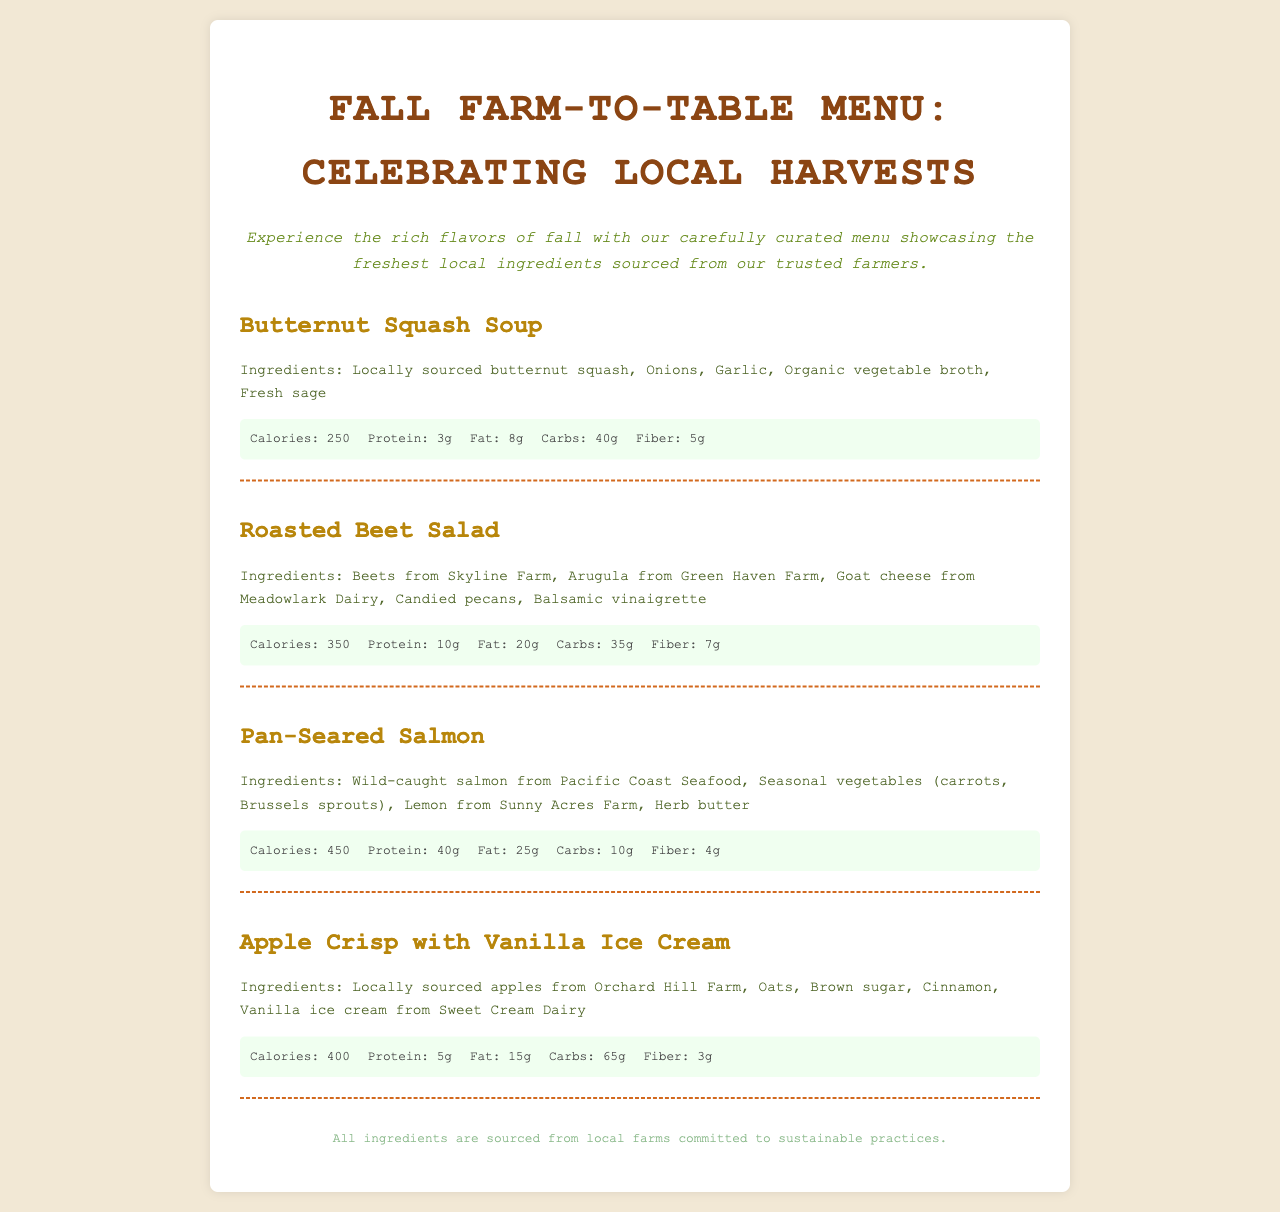what is the title of the menu? The title is prominently displayed at the top of the document.
Answer: Fall Farm-to-Table Menu: Celebrating Local Harvests how many calories are in the Pan-Seared Salmon? The nutrition information for each menu item includes calories, which is specified under the Pan-Seared Salmon.
Answer: 450 which farm provides the butternut squash? The ingredients for the Butternut Squash Soup are listed along with their sources, specifically from the local farms.
Answer: Locally sourced what is the primary protein source in the Roasted Beet Salad? The protein content is listed, along with the ingredients. Goat cheese is specifically mentioned as a key ingredient for protein.
Answer: Goat cheese what is the main ingredient in the Apple Crisp? The ingredients list for the Apple Crisp includes apples, which are the base of the dish.
Answer: Apples which dish has the highest fat content? By comparing the fat values listed in the nutrition sections, you can identify the dish with the highest amount.
Answer: Pan-Seared Salmon how many grams of fiber are in the Butternut Squash Soup? The fiber content is specified in the nutrition section of the Butternut Squash Soup.
Answer: 5g what ingredient is used for the dressing in the Roasted Beet Salad? The ingredients of the salad include specific items, including the dressing type noted at the end.
Answer: Balsamic vinaigrette what dessert is featured on the menu? The dessert is clearly listed at the end of the menu under a separate item.
Answer: Apple Crisp with Vanilla Ice Cream 